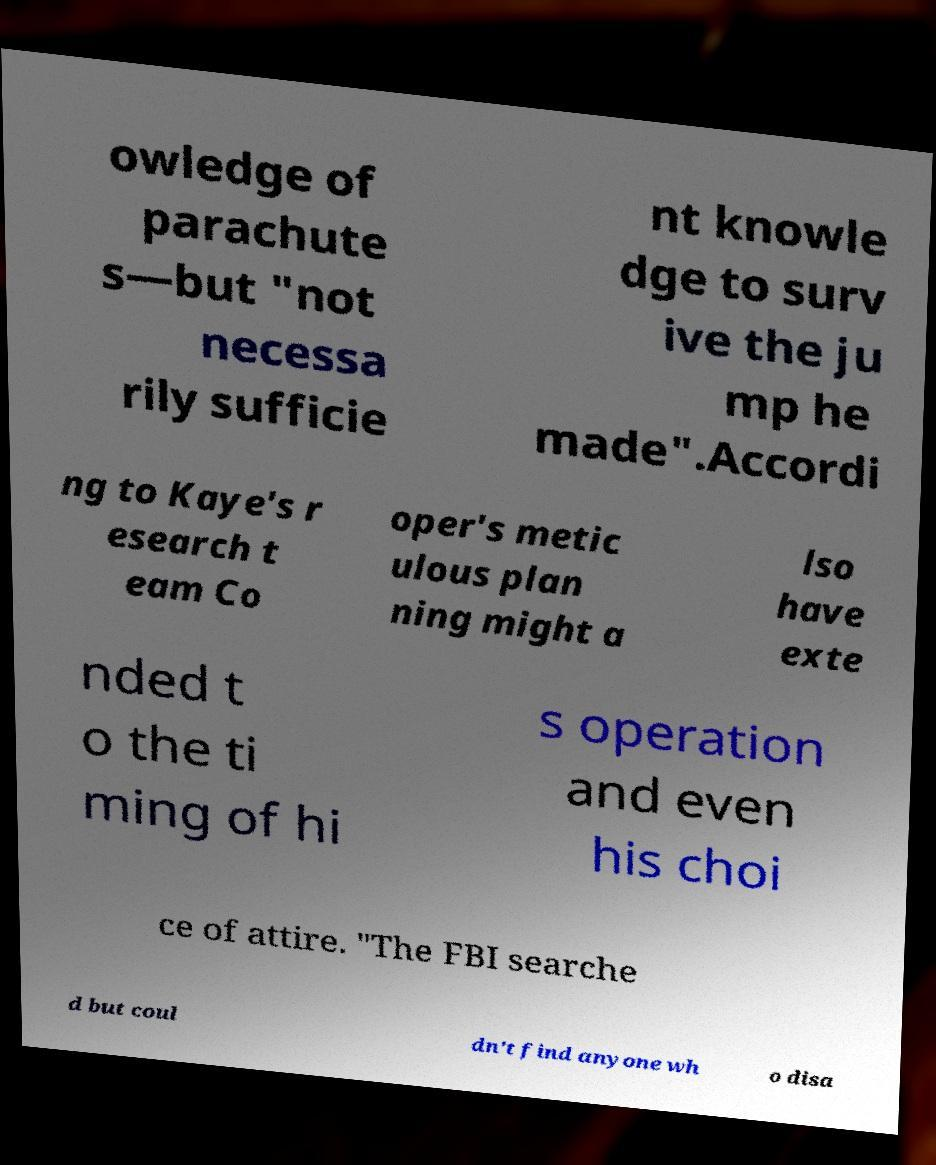There's text embedded in this image that I need extracted. Can you transcribe it verbatim? owledge of parachute s—but "not necessa rily sufficie nt knowle dge to surv ive the ju mp he made".Accordi ng to Kaye's r esearch t eam Co oper's metic ulous plan ning might a lso have exte nded t o the ti ming of hi s operation and even his choi ce of attire. "The FBI searche d but coul dn't find anyone wh o disa 